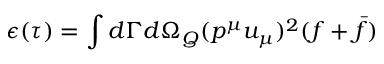<formula> <loc_0><loc_0><loc_500><loc_500>\epsilon ( \tau ) = \int d \Gamma d { \Omega } _ { Q } ( p ^ { \mu } u _ { \mu } ) ^ { 2 } ( f + \bar { f } )</formula> 